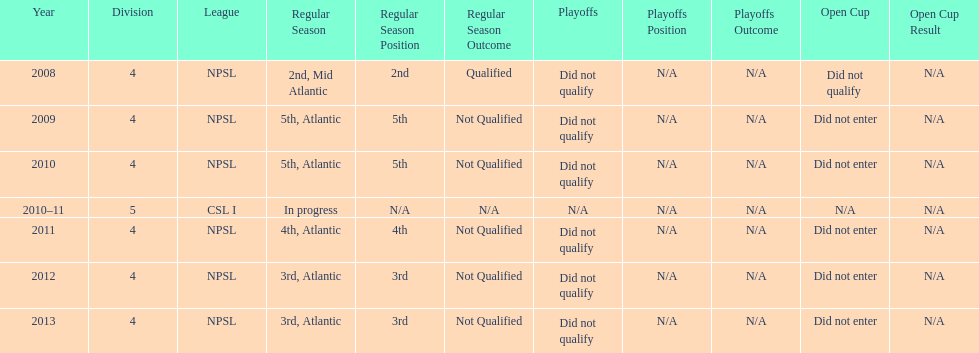How many years did they not qualify for the playoffs? 6. 